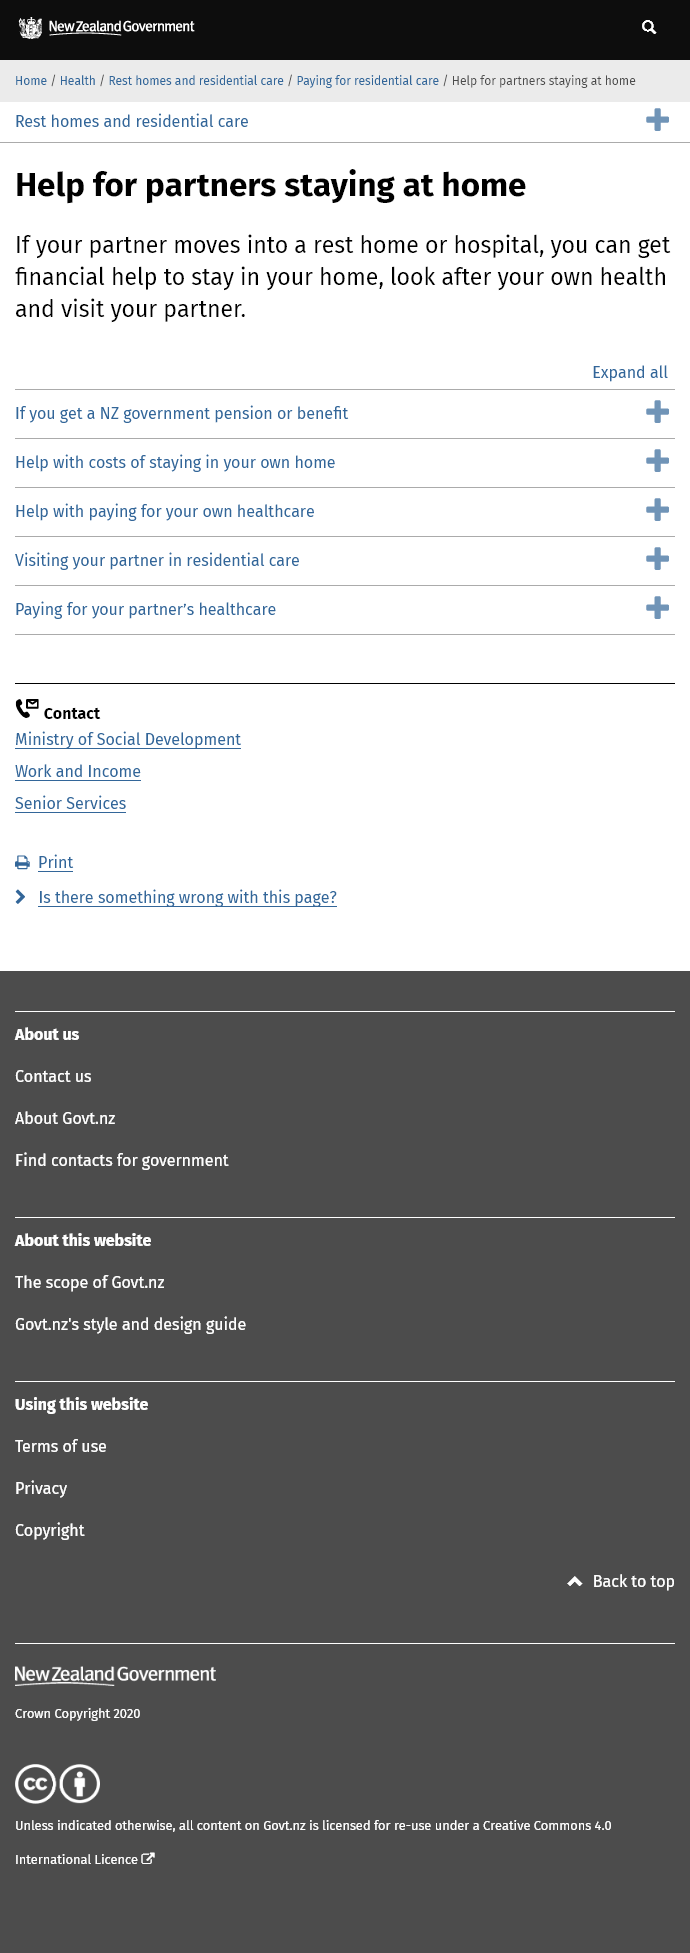List a handful of essential elements in this visual. Under the current circumstances, individuals who are in a relationship with a partner residing in a rest home or hospital are entitled to financial assistance. There is information available for assistance with the costs of staying in one's own home. I am able to obtain additional information regarding payment for my partner's healthcare if I click on the specific topic. 